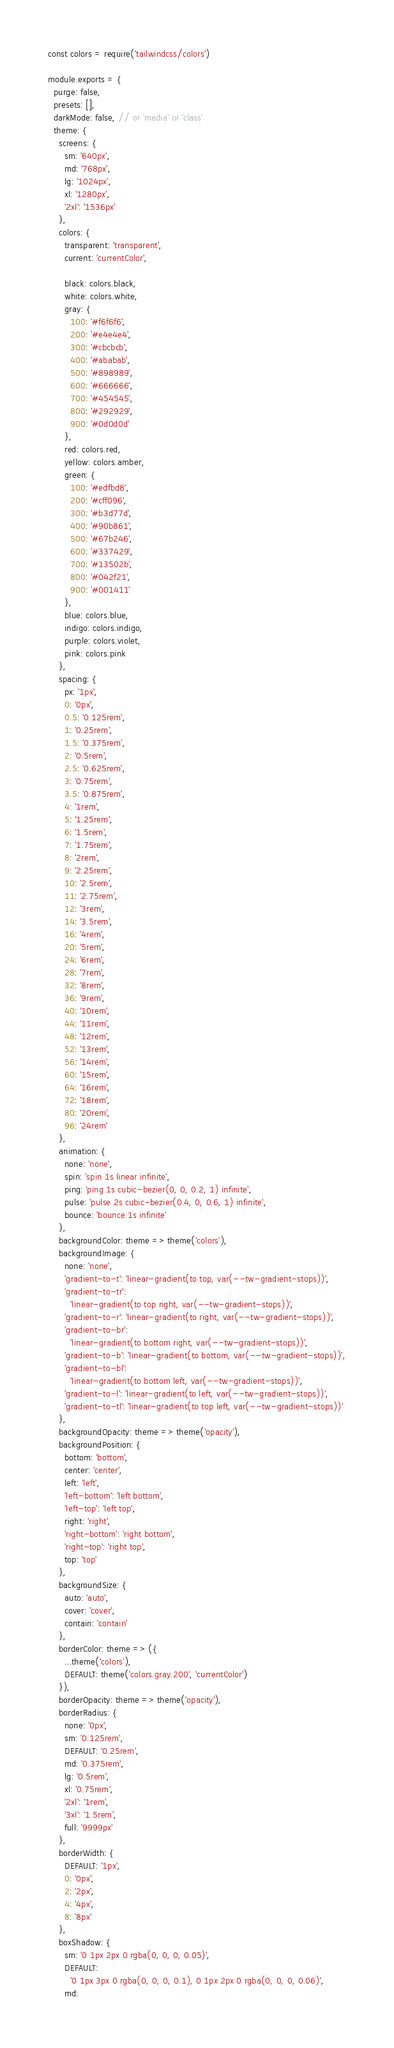Convert code to text. <code><loc_0><loc_0><loc_500><loc_500><_JavaScript_>const colors = require('tailwindcss/colors')

module.exports = {
  purge: false,
  presets: [],
  darkMode: false, // or 'media' or 'class'
  theme: {
    screens: {
      sm: '640px',
      md: '768px',
      lg: '1024px',
      xl: '1280px',
      '2xl': '1536px'
    },
    colors: {
      transparent: 'transparent',
      current: 'currentColor',

      black: colors.black,
      white: colors.white,
      gray: {
        100: '#f6f6f6',
        200: '#e4e4e4',
        300: '#cbcbcb',
        400: '#ababab',
        500: '#898989',
        600: '#666666',
        700: '#454545',
        800: '#292929',
        900: '#0d0d0d'
      },
      red: colors.red,
      yellow: colors.amber,
      green: {
        100: '#edfbd8',
        200: '#cff096',
        300: '#b3d77d',
        400: '#90b861',
        500: '#67b246',
        600: '#337429',
        700: '#13502b',
        800: '#042f21',
        900: '#001411'
      },
      blue: colors.blue,
      indigo: colors.indigo,
      purple: colors.violet,
      pink: colors.pink
    },
    spacing: {
      px: '1px',
      0: '0px',
      0.5: '0.125rem',
      1: '0.25rem',
      1.5: '0.375rem',
      2: '0.5rem',
      2.5: '0.625rem',
      3: '0.75rem',
      3.5: '0.875rem',
      4: '1rem',
      5: '1.25rem',
      6: '1.5rem',
      7: '1.75rem',
      8: '2rem',
      9: '2.25rem',
      10: '2.5rem',
      11: '2.75rem',
      12: '3rem',
      14: '3.5rem',
      16: '4rem',
      20: '5rem',
      24: '6rem',
      28: '7rem',
      32: '8rem',
      36: '9rem',
      40: '10rem',
      44: '11rem',
      48: '12rem',
      52: '13rem',
      56: '14rem',
      60: '15rem',
      64: '16rem',
      72: '18rem',
      80: '20rem',
      96: '24rem'
    },
    animation: {
      none: 'none',
      spin: 'spin 1s linear infinite',
      ping: 'ping 1s cubic-bezier(0, 0, 0.2, 1) infinite',
      pulse: 'pulse 2s cubic-bezier(0.4, 0, 0.6, 1) infinite',
      bounce: 'bounce 1s infinite'
    },
    backgroundColor: theme => theme('colors'),
    backgroundImage: {
      none: 'none',
      'gradient-to-t': 'linear-gradient(to top, var(--tw-gradient-stops))',
      'gradient-to-tr':
        'linear-gradient(to top right, var(--tw-gradient-stops))',
      'gradient-to-r': 'linear-gradient(to right, var(--tw-gradient-stops))',
      'gradient-to-br':
        'linear-gradient(to bottom right, var(--tw-gradient-stops))',
      'gradient-to-b': 'linear-gradient(to bottom, var(--tw-gradient-stops))',
      'gradient-to-bl':
        'linear-gradient(to bottom left, var(--tw-gradient-stops))',
      'gradient-to-l': 'linear-gradient(to left, var(--tw-gradient-stops))',
      'gradient-to-tl': 'linear-gradient(to top left, var(--tw-gradient-stops))'
    },
    backgroundOpacity: theme => theme('opacity'),
    backgroundPosition: {
      bottom: 'bottom',
      center: 'center',
      left: 'left',
      'left-bottom': 'left bottom',
      'left-top': 'left top',
      right: 'right',
      'right-bottom': 'right bottom',
      'right-top': 'right top',
      top: 'top'
    },
    backgroundSize: {
      auto: 'auto',
      cover: 'cover',
      contain: 'contain'
    },
    borderColor: theme => ({
      ...theme('colors'),
      DEFAULT: theme('colors.gray.200', 'currentColor')
    }),
    borderOpacity: theme => theme('opacity'),
    borderRadius: {
      none: '0px',
      sm: '0.125rem',
      DEFAULT: '0.25rem',
      md: '0.375rem',
      lg: '0.5rem',
      xl: '0.75rem',
      '2xl': '1rem',
      '3xl': '1.5rem',
      full: '9999px'
    },
    borderWidth: {
      DEFAULT: '1px',
      0: '0px',
      2: '2px',
      4: '4px',
      8: '8px'
    },
    boxShadow: {
      sm: '0 1px 2px 0 rgba(0, 0, 0, 0.05)',
      DEFAULT:
        '0 1px 3px 0 rgba(0, 0, 0, 0.1), 0 1px 2px 0 rgba(0, 0, 0, 0.06)',
      md:</code> 